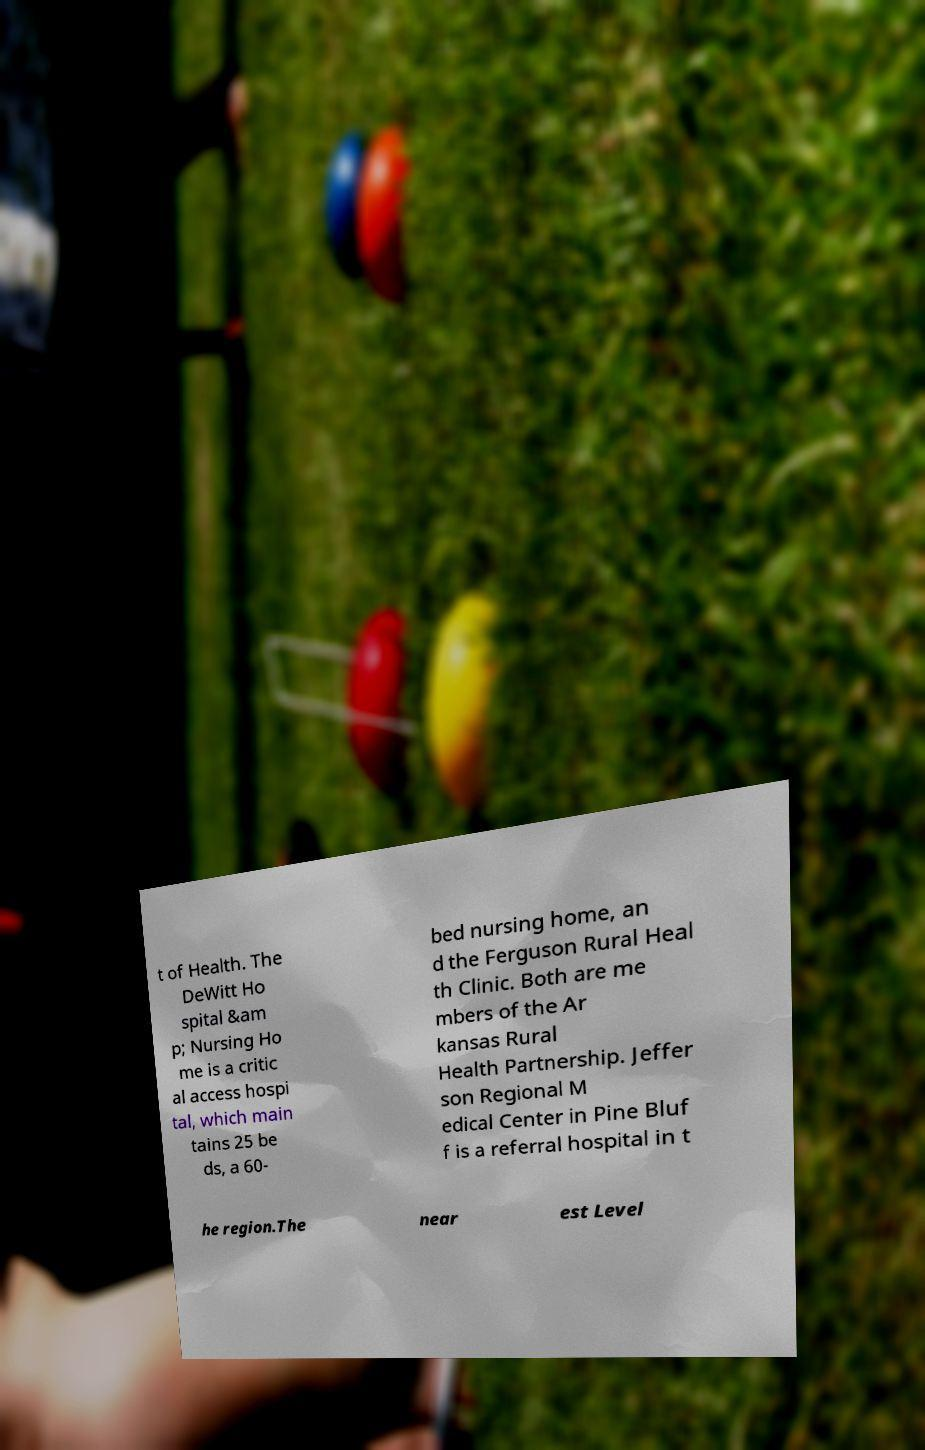Could you extract and type out the text from this image? t of Health. The DeWitt Ho spital &am p; Nursing Ho me is a critic al access hospi tal, which main tains 25 be ds, a 60- bed nursing home, an d the Ferguson Rural Heal th Clinic. Both are me mbers of the Ar kansas Rural Health Partnership. Jeffer son Regional M edical Center in Pine Bluf f is a referral hospital in t he region.The near est Level 